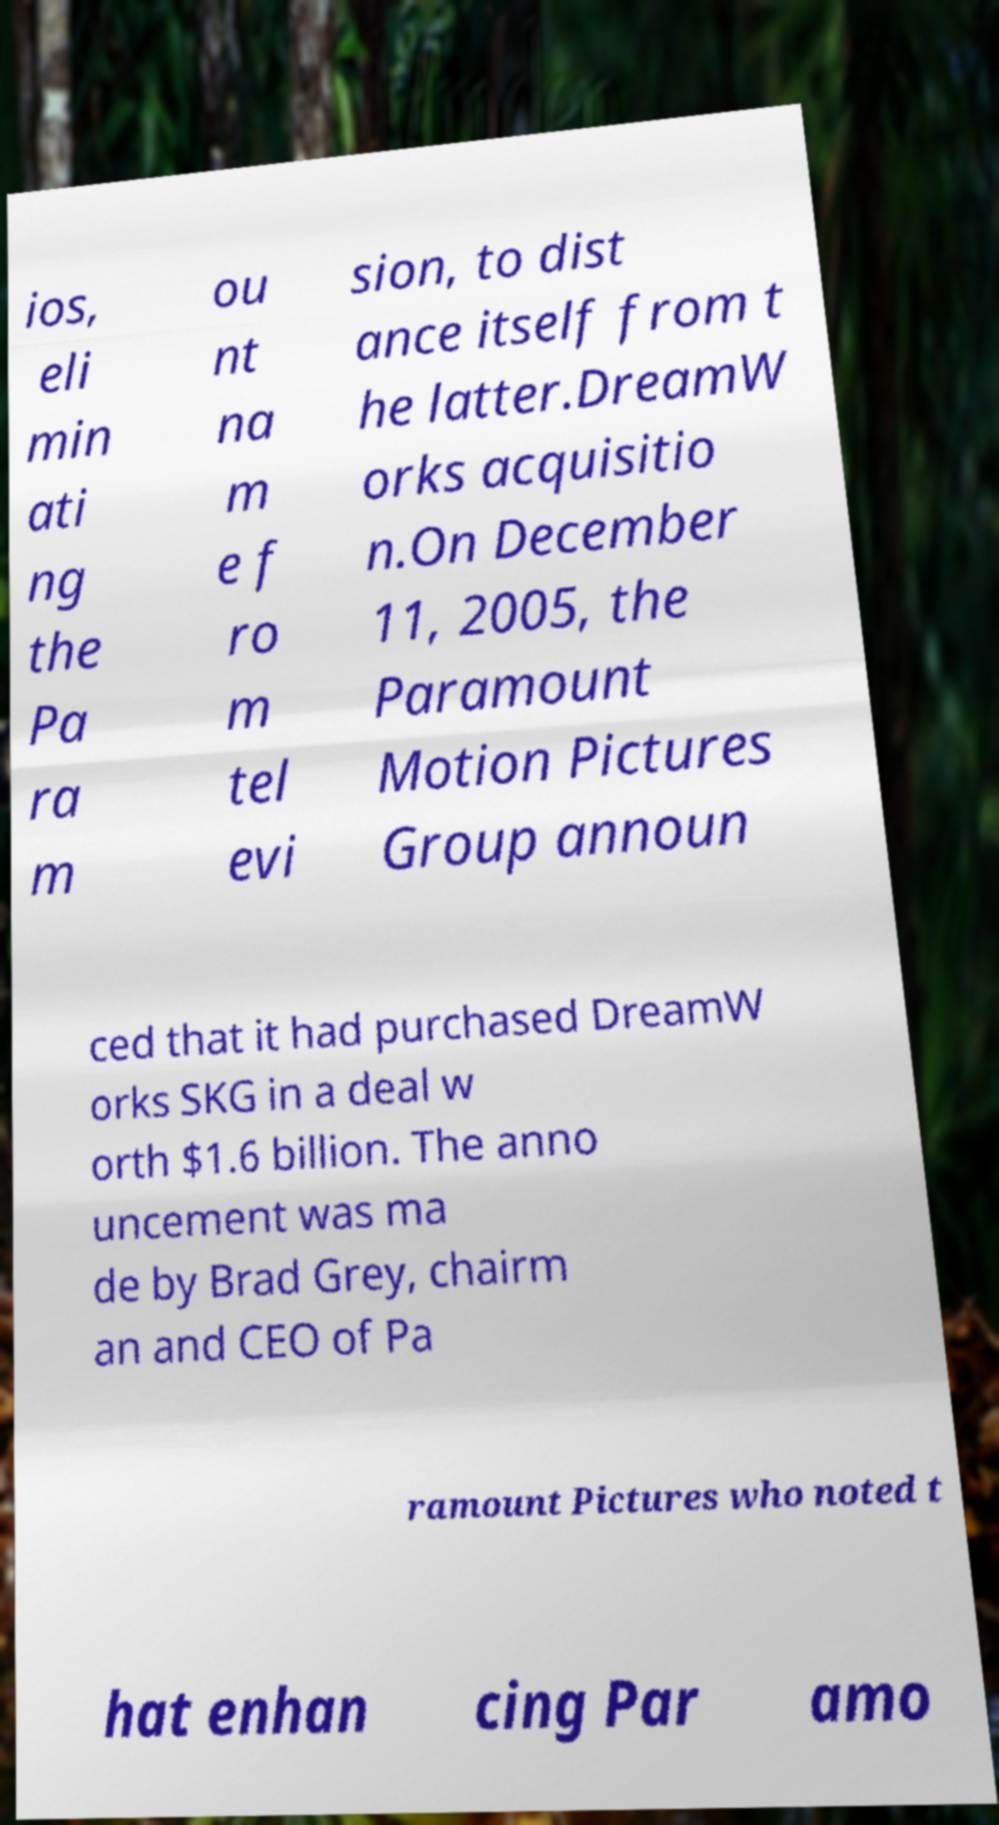Can you accurately transcribe the text from the provided image for me? ios, eli min ati ng the Pa ra m ou nt na m e f ro m tel evi sion, to dist ance itself from t he latter.DreamW orks acquisitio n.On December 11, 2005, the Paramount Motion Pictures Group announ ced that it had purchased DreamW orks SKG in a deal w orth $1.6 billion. The anno uncement was ma de by Brad Grey, chairm an and CEO of Pa ramount Pictures who noted t hat enhan cing Par amo 